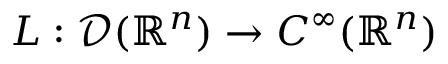<formula> <loc_0><loc_0><loc_500><loc_500>L \colon { \mathcal { D } } ( \mathbb { R } ^ { n } ) \to C ^ { \infty } ( \mathbb { R } ^ { n } )</formula> 